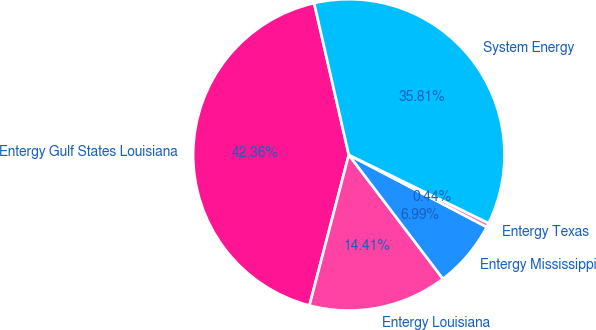Convert chart to OTSL. <chart><loc_0><loc_0><loc_500><loc_500><pie_chart><fcel>Entergy Gulf States Louisiana<fcel>Entergy Louisiana<fcel>Entergy Mississippi<fcel>Entergy Texas<fcel>System Energy<nl><fcel>42.36%<fcel>14.41%<fcel>6.99%<fcel>0.44%<fcel>35.81%<nl></chart> 